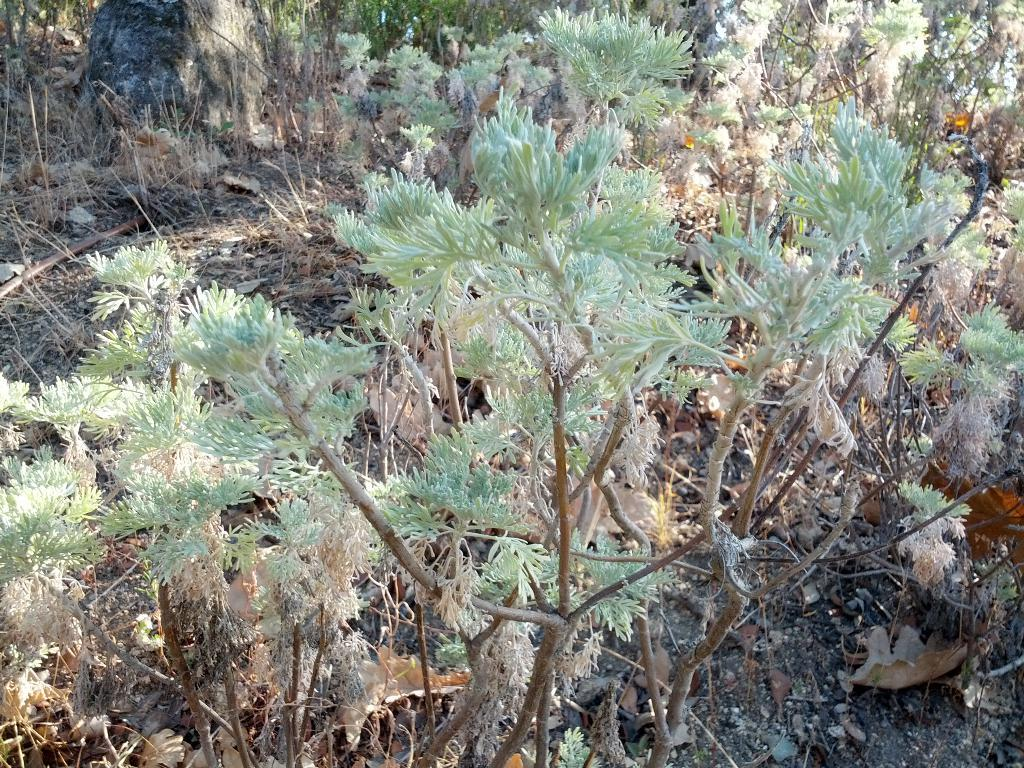What type of vegetation can be seen in the image? There are plants and grass visible in the image. What is the condition of the leaves on the plants in the image? Dried leaves are present in the image. What type of record can be seen being played by the plants in the image? There is no record or any indication of music playing in the image. 